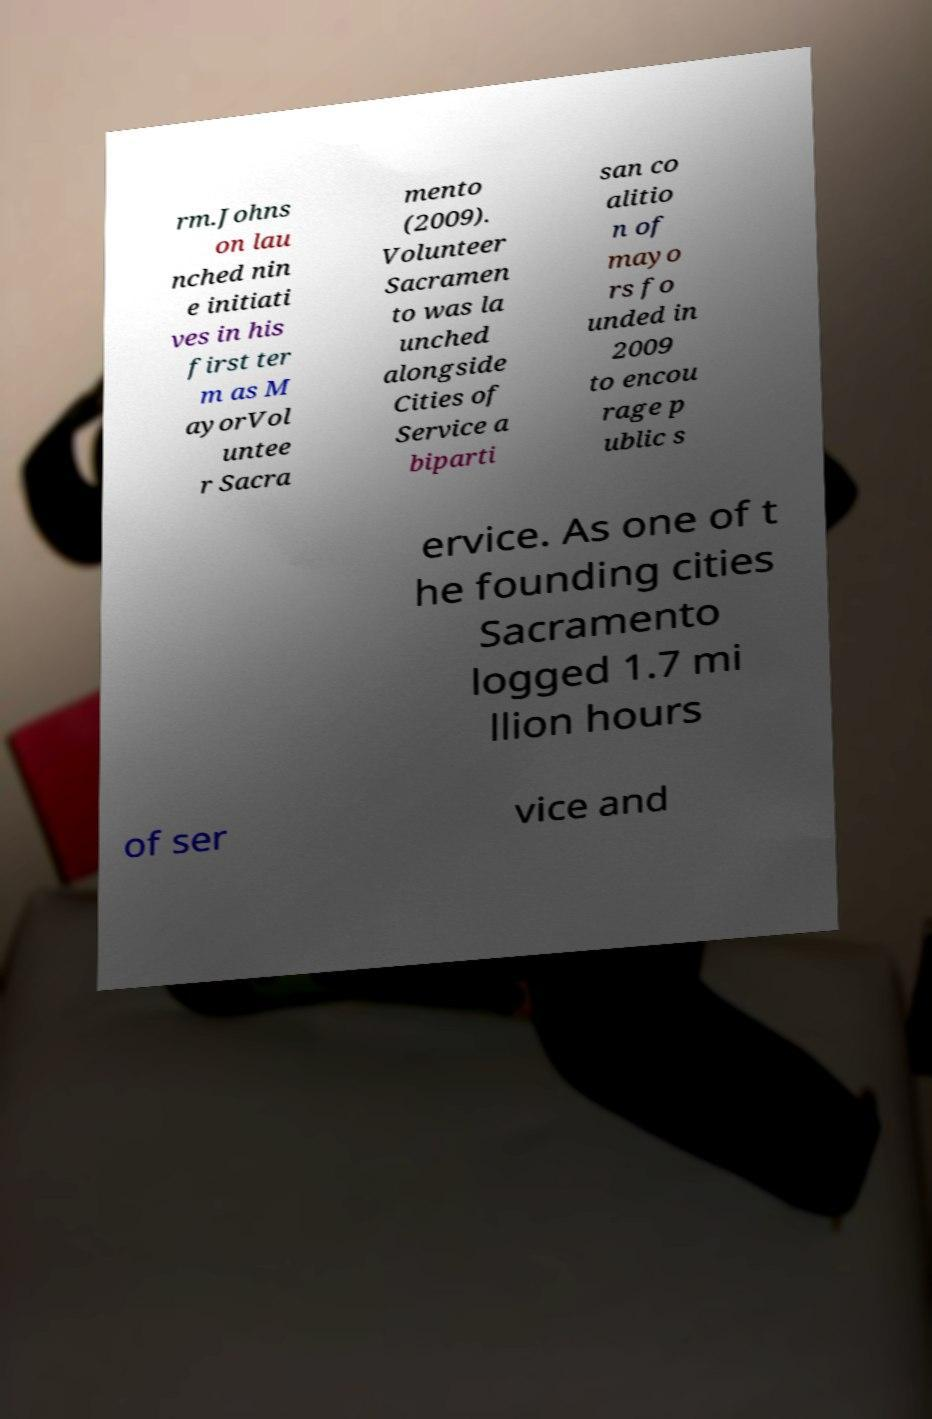For documentation purposes, I need the text within this image transcribed. Could you provide that? rm.Johns on lau nched nin e initiati ves in his first ter m as M ayorVol untee r Sacra mento (2009). Volunteer Sacramen to was la unched alongside Cities of Service a biparti san co alitio n of mayo rs fo unded in 2009 to encou rage p ublic s ervice. As one of t he founding cities Sacramento logged 1.7 mi llion hours of ser vice and 